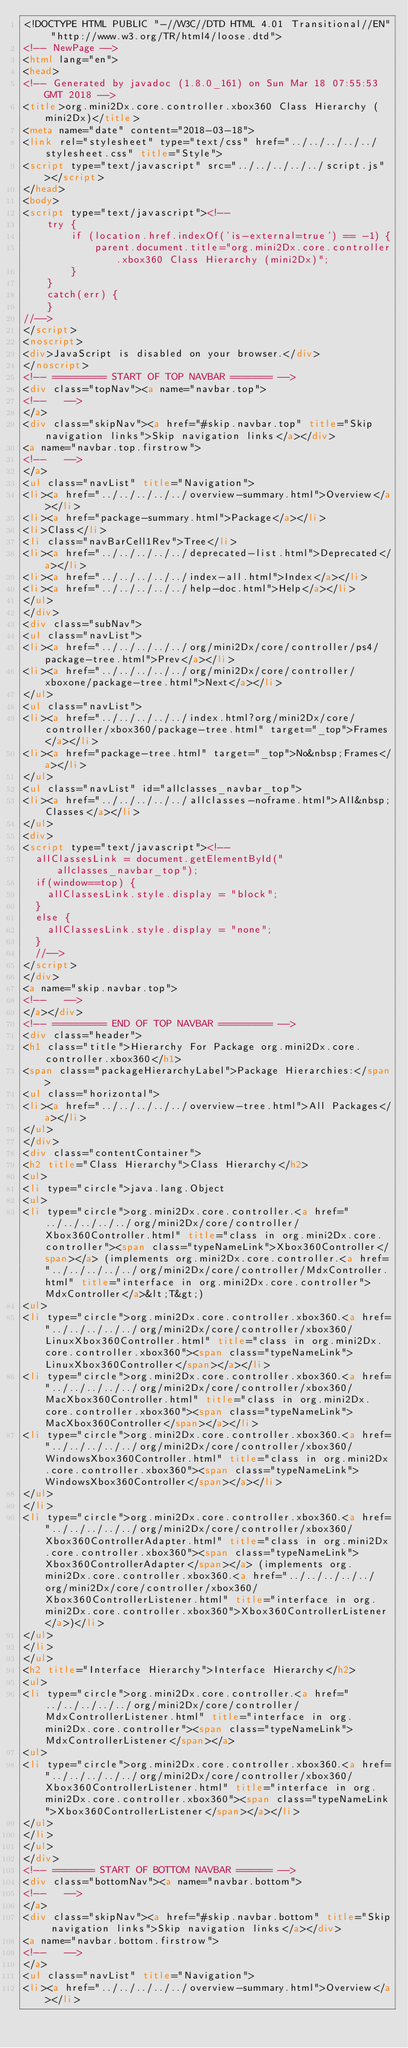Convert code to text. <code><loc_0><loc_0><loc_500><loc_500><_HTML_><!DOCTYPE HTML PUBLIC "-//W3C//DTD HTML 4.01 Transitional//EN" "http://www.w3.org/TR/html4/loose.dtd">
<!-- NewPage -->
<html lang="en">
<head>
<!-- Generated by javadoc (1.8.0_161) on Sun Mar 18 07:55:53 GMT 2018 -->
<title>org.mini2Dx.core.controller.xbox360 Class Hierarchy (mini2Dx)</title>
<meta name="date" content="2018-03-18">
<link rel="stylesheet" type="text/css" href="../../../../../stylesheet.css" title="Style">
<script type="text/javascript" src="../../../../../script.js"></script>
</head>
<body>
<script type="text/javascript"><!--
    try {
        if (location.href.indexOf('is-external=true') == -1) {
            parent.document.title="org.mini2Dx.core.controller.xbox360 Class Hierarchy (mini2Dx)";
        }
    }
    catch(err) {
    }
//-->
</script>
<noscript>
<div>JavaScript is disabled on your browser.</div>
</noscript>
<!-- ========= START OF TOP NAVBAR ======= -->
<div class="topNav"><a name="navbar.top">
<!--   -->
</a>
<div class="skipNav"><a href="#skip.navbar.top" title="Skip navigation links">Skip navigation links</a></div>
<a name="navbar.top.firstrow">
<!--   -->
</a>
<ul class="navList" title="Navigation">
<li><a href="../../../../../overview-summary.html">Overview</a></li>
<li><a href="package-summary.html">Package</a></li>
<li>Class</li>
<li class="navBarCell1Rev">Tree</li>
<li><a href="../../../../../deprecated-list.html">Deprecated</a></li>
<li><a href="../../../../../index-all.html">Index</a></li>
<li><a href="../../../../../help-doc.html">Help</a></li>
</ul>
</div>
<div class="subNav">
<ul class="navList">
<li><a href="../../../../../org/mini2Dx/core/controller/ps4/package-tree.html">Prev</a></li>
<li><a href="../../../../../org/mini2Dx/core/controller/xboxone/package-tree.html">Next</a></li>
</ul>
<ul class="navList">
<li><a href="../../../../../index.html?org/mini2Dx/core/controller/xbox360/package-tree.html" target="_top">Frames</a></li>
<li><a href="package-tree.html" target="_top">No&nbsp;Frames</a></li>
</ul>
<ul class="navList" id="allclasses_navbar_top">
<li><a href="../../../../../allclasses-noframe.html">All&nbsp;Classes</a></li>
</ul>
<div>
<script type="text/javascript"><!--
  allClassesLink = document.getElementById("allclasses_navbar_top");
  if(window==top) {
    allClassesLink.style.display = "block";
  }
  else {
    allClassesLink.style.display = "none";
  }
  //-->
</script>
</div>
<a name="skip.navbar.top">
<!--   -->
</a></div>
<!-- ========= END OF TOP NAVBAR ========= -->
<div class="header">
<h1 class="title">Hierarchy For Package org.mini2Dx.core.controller.xbox360</h1>
<span class="packageHierarchyLabel">Package Hierarchies:</span>
<ul class="horizontal">
<li><a href="../../../../../overview-tree.html">All Packages</a></li>
</ul>
</div>
<div class="contentContainer">
<h2 title="Class Hierarchy">Class Hierarchy</h2>
<ul>
<li type="circle">java.lang.Object
<ul>
<li type="circle">org.mini2Dx.core.controller.<a href="../../../../../org/mini2Dx/core/controller/Xbox360Controller.html" title="class in org.mini2Dx.core.controller"><span class="typeNameLink">Xbox360Controller</span></a> (implements org.mini2Dx.core.controller.<a href="../../../../../org/mini2Dx/core/controller/MdxController.html" title="interface in org.mini2Dx.core.controller">MdxController</a>&lt;T&gt;)
<ul>
<li type="circle">org.mini2Dx.core.controller.xbox360.<a href="../../../../../org/mini2Dx/core/controller/xbox360/LinuxXbox360Controller.html" title="class in org.mini2Dx.core.controller.xbox360"><span class="typeNameLink">LinuxXbox360Controller</span></a></li>
<li type="circle">org.mini2Dx.core.controller.xbox360.<a href="../../../../../org/mini2Dx/core/controller/xbox360/MacXbox360Controller.html" title="class in org.mini2Dx.core.controller.xbox360"><span class="typeNameLink">MacXbox360Controller</span></a></li>
<li type="circle">org.mini2Dx.core.controller.xbox360.<a href="../../../../../org/mini2Dx/core/controller/xbox360/WindowsXbox360Controller.html" title="class in org.mini2Dx.core.controller.xbox360"><span class="typeNameLink">WindowsXbox360Controller</span></a></li>
</ul>
</li>
<li type="circle">org.mini2Dx.core.controller.xbox360.<a href="../../../../../org/mini2Dx/core/controller/xbox360/Xbox360ControllerAdapter.html" title="class in org.mini2Dx.core.controller.xbox360"><span class="typeNameLink">Xbox360ControllerAdapter</span></a> (implements org.mini2Dx.core.controller.xbox360.<a href="../../../../../org/mini2Dx/core/controller/xbox360/Xbox360ControllerListener.html" title="interface in org.mini2Dx.core.controller.xbox360">Xbox360ControllerListener</a>)</li>
</ul>
</li>
</ul>
<h2 title="Interface Hierarchy">Interface Hierarchy</h2>
<ul>
<li type="circle">org.mini2Dx.core.controller.<a href="../../../../../org/mini2Dx/core/controller/MdxControllerListener.html" title="interface in org.mini2Dx.core.controller"><span class="typeNameLink">MdxControllerListener</span></a>
<ul>
<li type="circle">org.mini2Dx.core.controller.xbox360.<a href="../../../../../org/mini2Dx/core/controller/xbox360/Xbox360ControllerListener.html" title="interface in org.mini2Dx.core.controller.xbox360"><span class="typeNameLink">Xbox360ControllerListener</span></a></li>
</ul>
</li>
</ul>
</div>
<!-- ======= START OF BOTTOM NAVBAR ====== -->
<div class="bottomNav"><a name="navbar.bottom">
<!--   -->
</a>
<div class="skipNav"><a href="#skip.navbar.bottom" title="Skip navigation links">Skip navigation links</a></div>
<a name="navbar.bottom.firstrow">
<!--   -->
</a>
<ul class="navList" title="Navigation">
<li><a href="../../../../../overview-summary.html">Overview</a></li></code> 